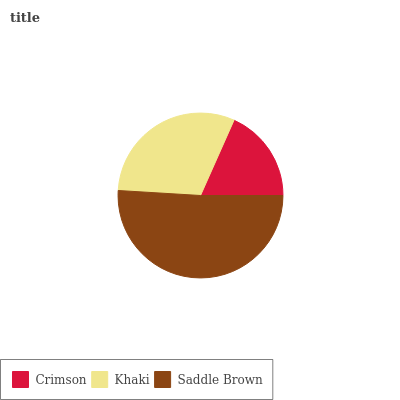Is Crimson the minimum?
Answer yes or no. Yes. Is Saddle Brown the maximum?
Answer yes or no. Yes. Is Khaki the minimum?
Answer yes or no. No. Is Khaki the maximum?
Answer yes or no. No. Is Khaki greater than Crimson?
Answer yes or no. Yes. Is Crimson less than Khaki?
Answer yes or no. Yes. Is Crimson greater than Khaki?
Answer yes or no. No. Is Khaki less than Crimson?
Answer yes or no. No. Is Khaki the high median?
Answer yes or no. Yes. Is Khaki the low median?
Answer yes or no. Yes. Is Crimson the high median?
Answer yes or no. No. Is Saddle Brown the low median?
Answer yes or no. No. 